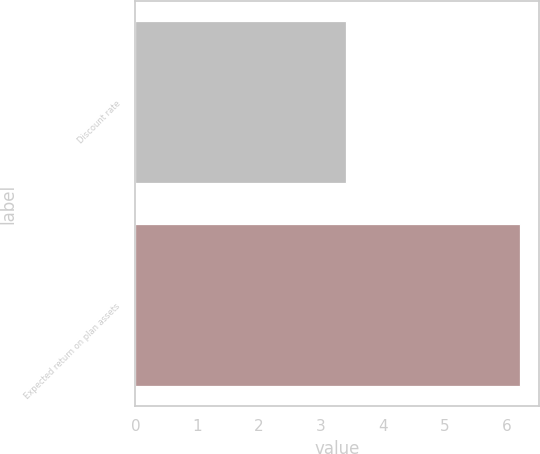Convert chart. <chart><loc_0><loc_0><loc_500><loc_500><bar_chart><fcel>Discount rate<fcel>Expected return on plan assets<nl><fcel>3.41<fcel>6.22<nl></chart> 